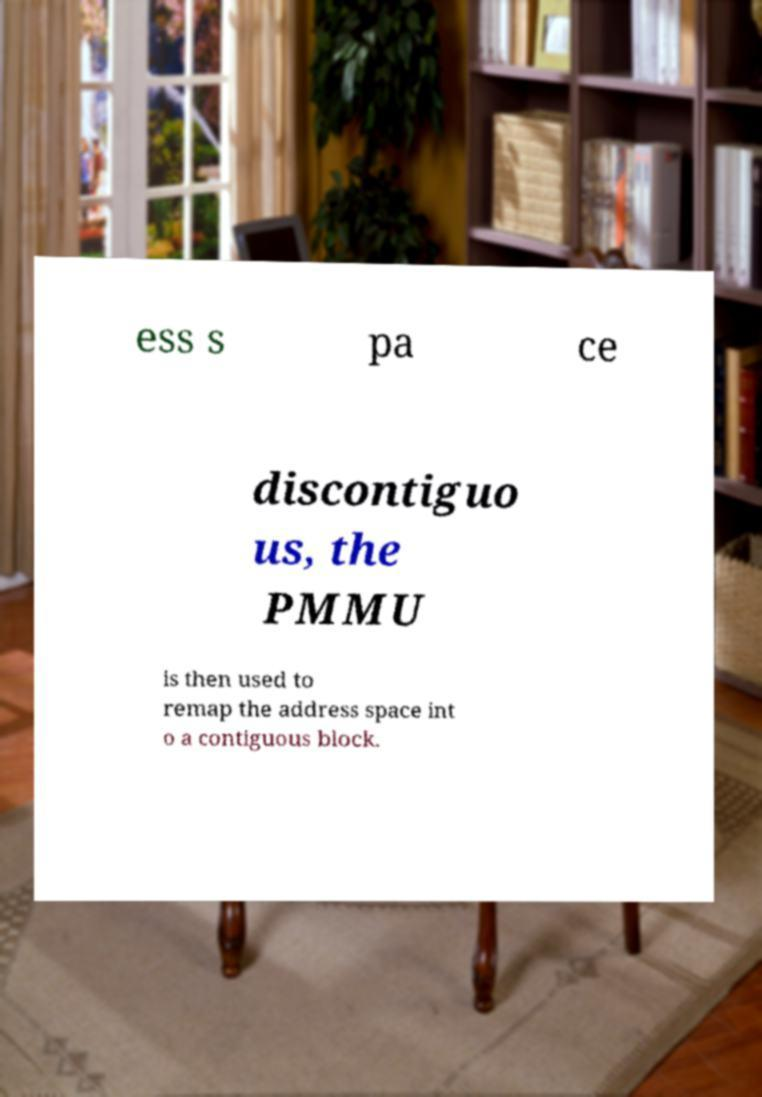Please read and relay the text visible in this image. What does it say? ess s pa ce discontiguo us, the PMMU is then used to remap the address space int o a contiguous block. 